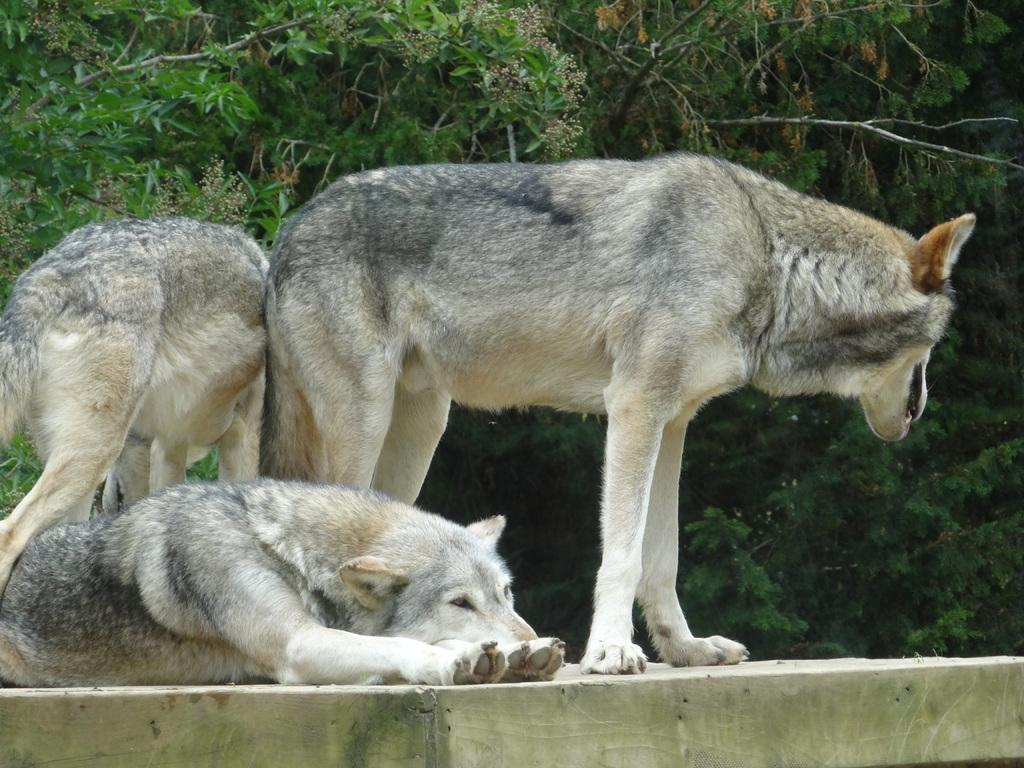What animals are present in the image? There is a group of wolves in the image. Where are the wolves located? The wolves are on the ground. What type of natural environment can be seen in the image? There are trees visible in the image. What type of meat is being served at the house in the image? There is no house or meat present in the image; it features a group of wolves on the ground with trees in the background. 